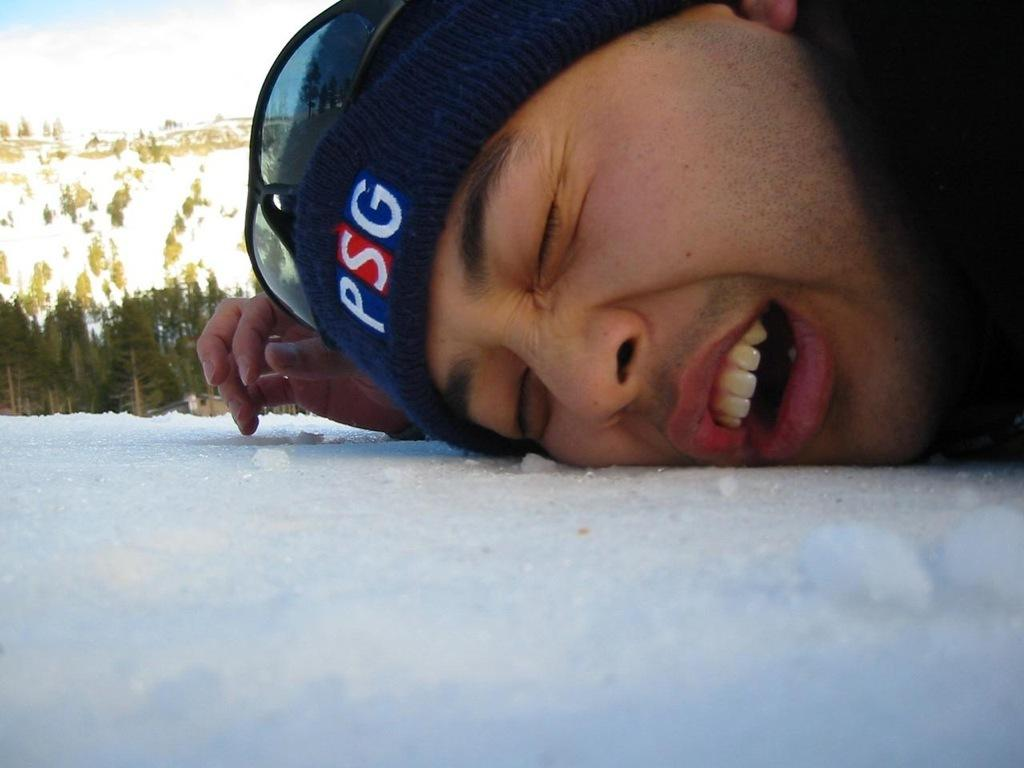Who or what is in the image? There is a person in the image. What is the person's face resting on? The person's face is on snow. What can be seen in the background of the image? There are trees and the sky visible in the background of the image. What are the person's beliefs about the hobbies they should follow according to the rule in the image? There is no mention of beliefs, hobbies, or rules in the image; it simply shows a person with their face on snow, surrounded by trees and the sky. 